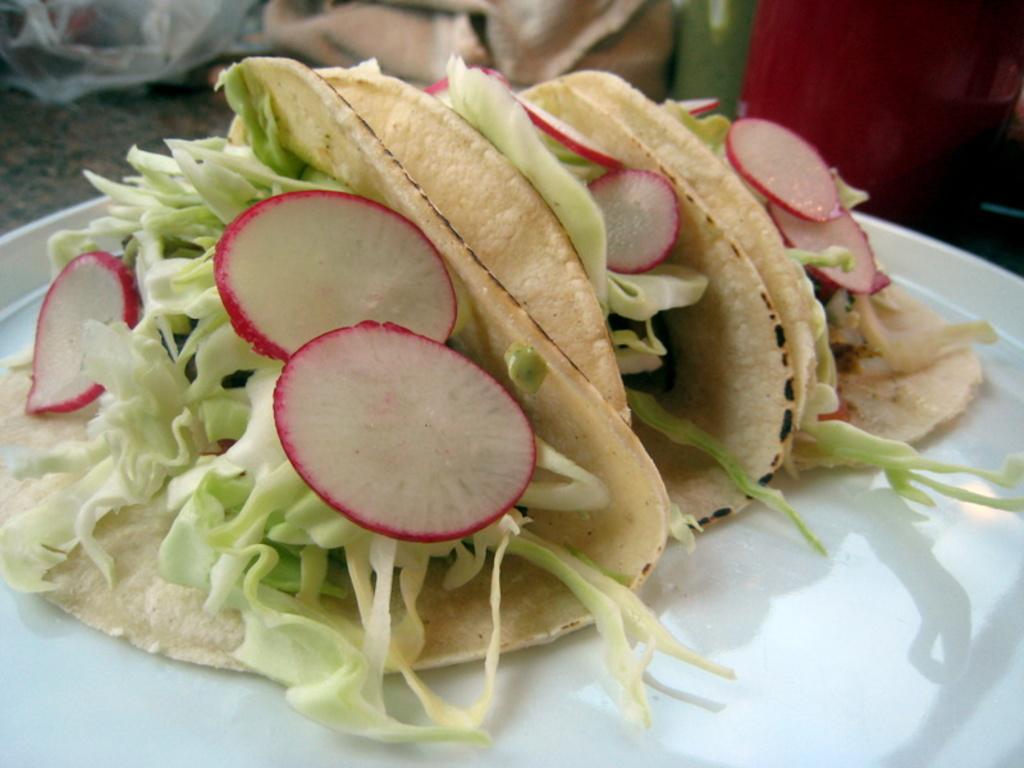In one or two sentences, can you explain what this image depicts? It is a zoom in picture of chopped cabbage and strawberries planted in rotis and these food items are placed in the white plate. 